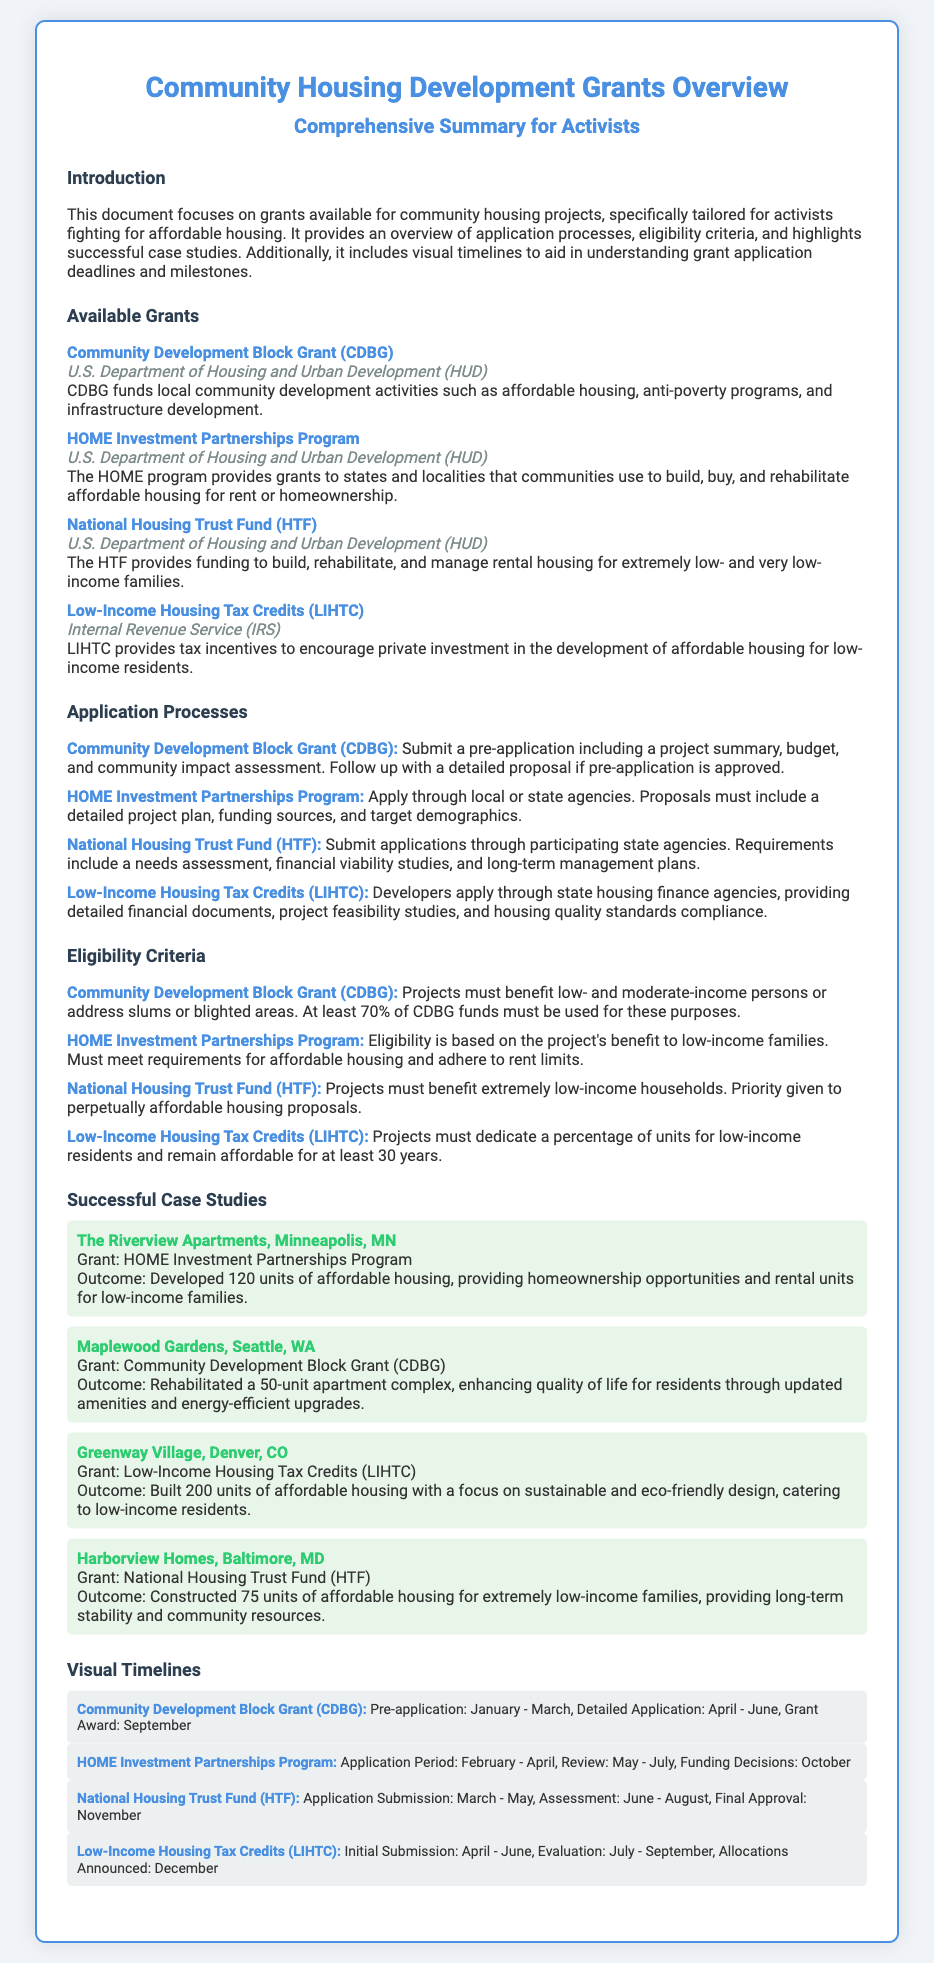What is the first available grant listed? The first available grant mentioned in the document is the "Community Development Block Grant (CDBG)."
Answer: Community Development Block Grant (CDBG) Who issues the HOME Investment Partnerships Program grant? The HOME Investment Partnerships Program grant is issued by the U.S. Department of Housing and Urban Development (HUD).
Answer: U.S. Department of Housing and Urban Development (HUD) What is required for eligibility for the National Housing Trust Fund? Projects must benefit extremely low-income households and priority is given to perpetually affordable housing proposals.
Answer: Extremely low-income households What is the application period for the Low-Income Housing Tax Credits? The initial submission period for the Low-Income Housing Tax Credits is from April to June.
Answer: April - June How many units were developed in The Riverview Apartments case study? The Riverview Apartments case study highlights the development of 120 units of affordable housing.
Answer: 120 units What grant did Maplewood Gardens receive? Maplewood Gardens received the Community Development Block Grant (CDBG).
Answer: Community Development Block Grant (CDBG) What is the total number of units in Greenway Village? Greenway Village is reported to have built 200 units of affordable housing.
Answer: 200 units What milestone is listed for the National Housing Trust Fund's final approval? The final approval for the National Housing Trust Fund is scheduled for November.
Answer: November 